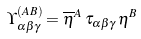<formula> <loc_0><loc_0><loc_500><loc_500>\Upsilon ^ { ( A B ) } _ { \alpha \beta \gamma } = \overline { \eta } ^ { A } \, \tau _ { \alpha \beta \gamma } \, \eta ^ { B }</formula> 